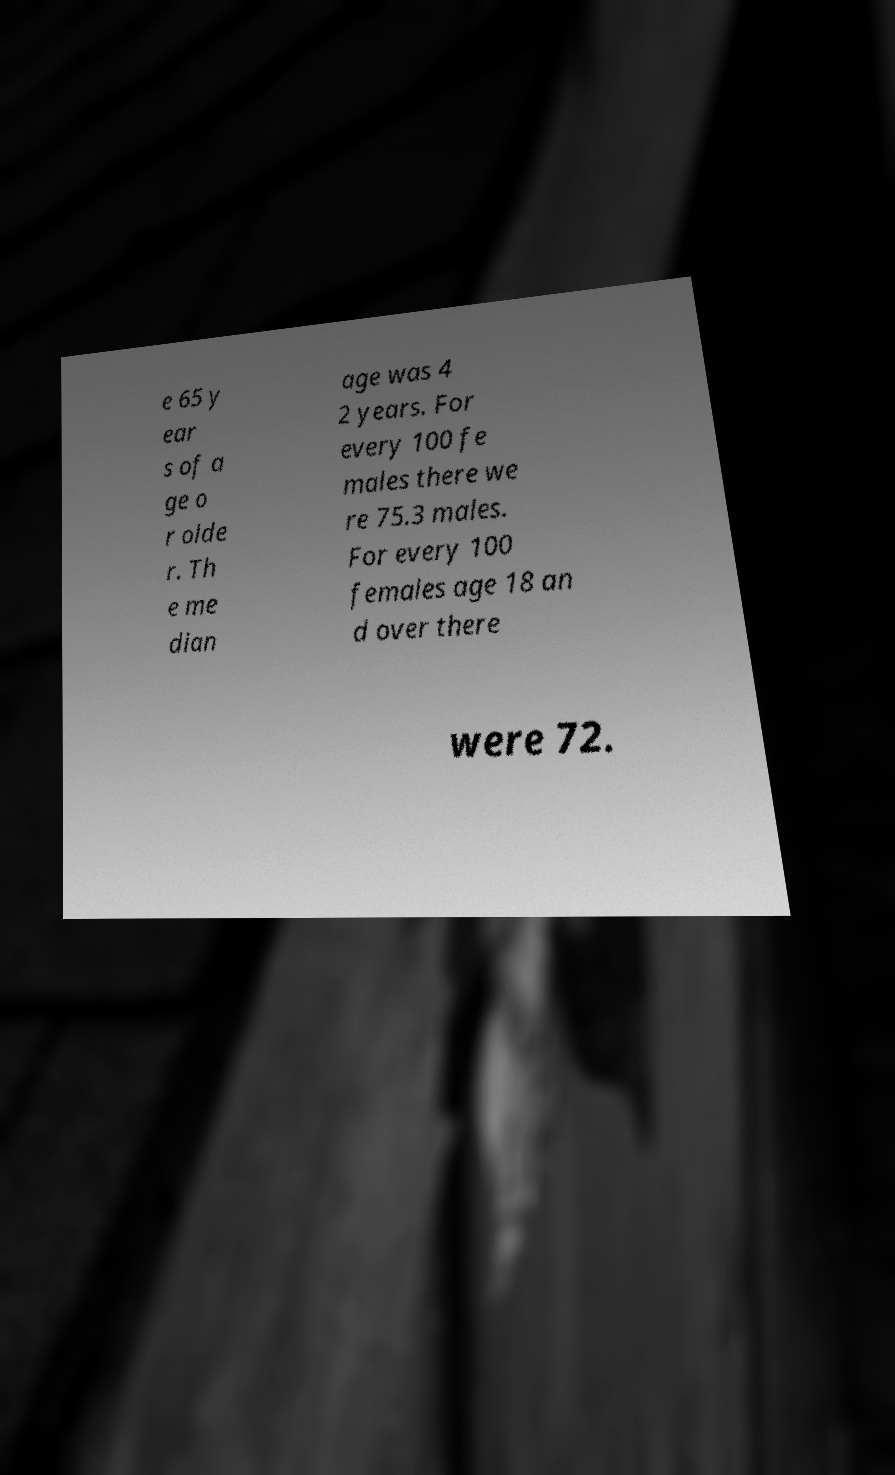For documentation purposes, I need the text within this image transcribed. Could you provide that? e 65 y ear s of a ge o r olde r. Th e me dian age was 4 2 years. For every 100 fe males there we re 75.3 males. For every 100 females age 18 an d over there were 72. 